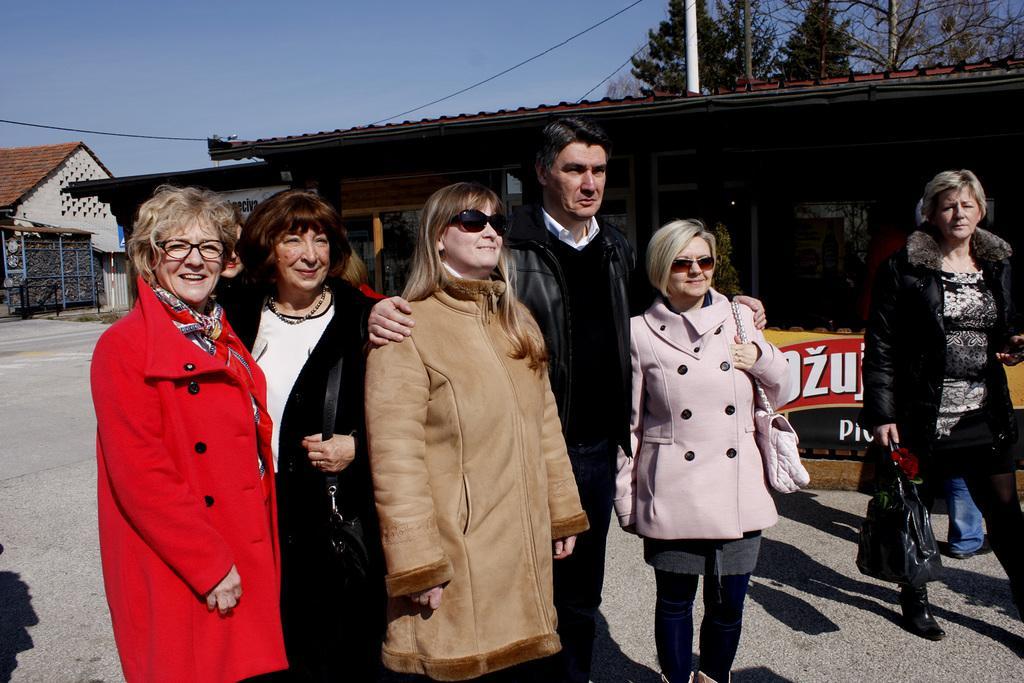Describe this image in one or two sentences. In this picture I can see group of people standing. There are buildings, trees and some other objects, and in the background there is the sky. 